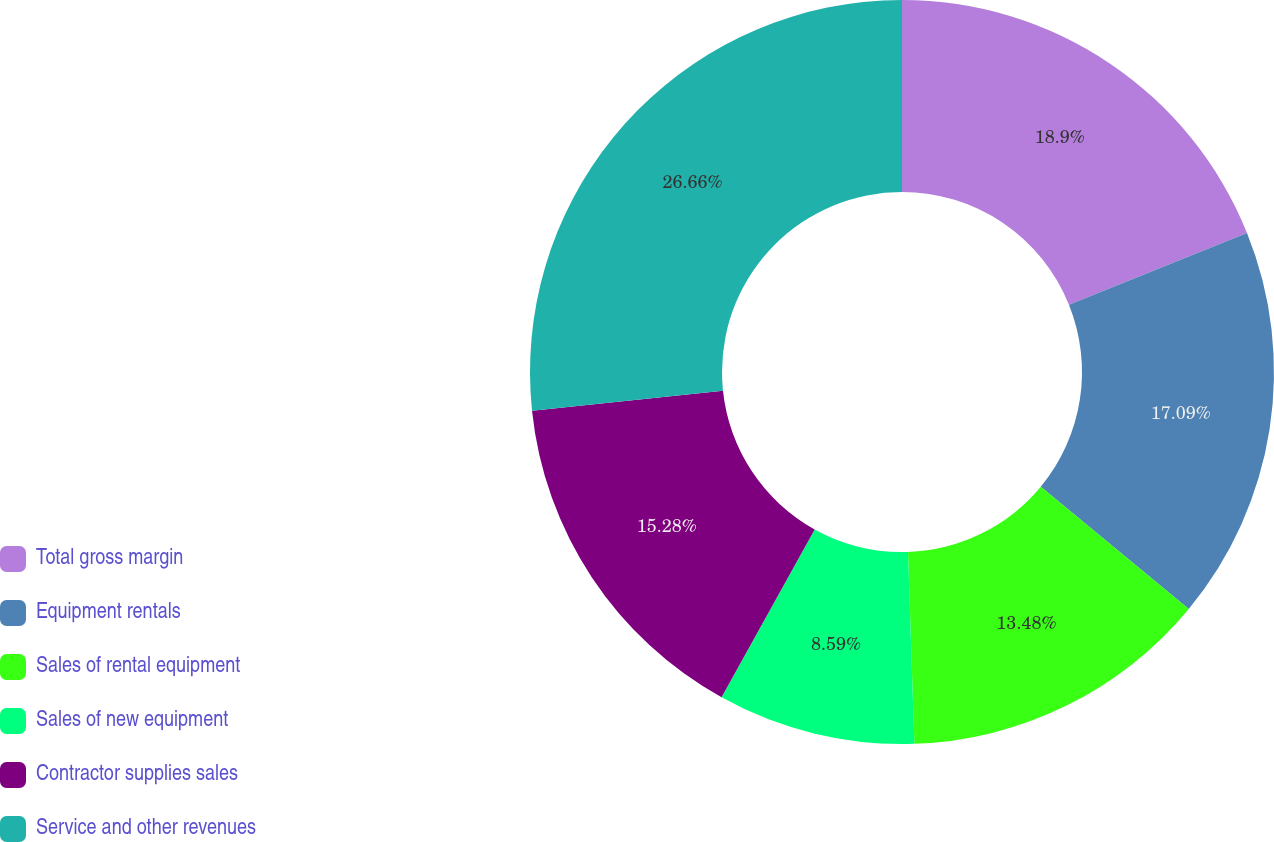Convert chart to OTSL. <chart><loc_0><loc_0><loc_500><loc_500><pie_chart><fcel>Total gross margin<fcel>Equipment rentals<fcel>Sales of rental equipment<fcel>Sales of new equipment<fcel>Contractor supplies sales<fcel>Service and other revenues<nl><fcel>18.9%<fcel>17.09%<fcel>13.48%<fcel>8.59%<fcel>15.28%<fcel>26.66%<nl></chart> 